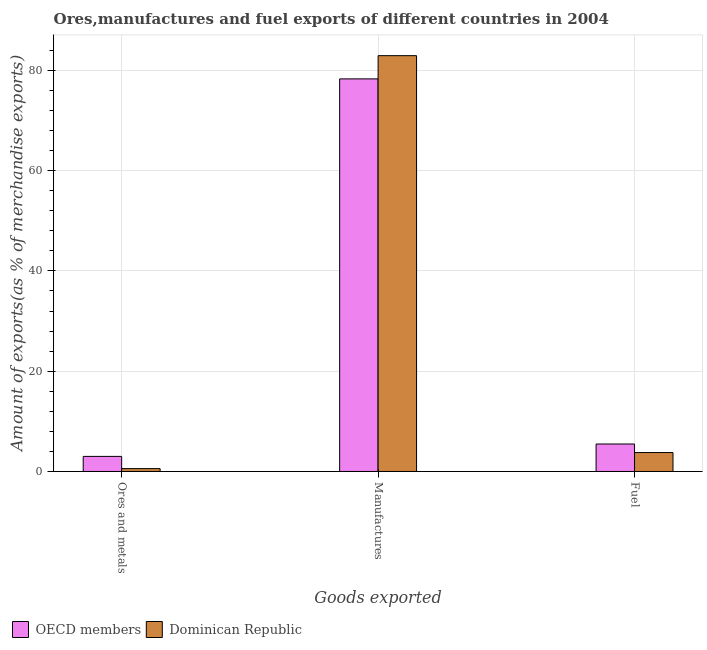How many groups of bars are there?
Your answer should be compact. 3. Are the number of bars per tick equal to the number of legend labels?
Offer a terse response. Yes. Are the number of bars on each tick of the X-axis equal?
Offer a terse response. Yes. What is the label of the 3rd group of bars from the left?
Give a very brief answer. Fuel. What is the percentage of manufactures exports in Dominican Republic?
Ensure brevity in your answer.  82.92. Across all countries, what is the maximum percentage of fuel exports?
Your answer should be compact. 5.48. Across all countries, what is the minimum percentage of ores and metals exports?
Give a very brief answer. 0.57. What is the total percentage of manufactures exports in the graph?
Keep it short and to the point. 161.21. What is the difference between the percentage of manufactures exports in Dominican Republic and that in OECD members?
Your answer should be very brief. 4.63. What is the difference between the percentage of fuel exports in OECD members and the percentage of ores and metals exports in Dominican Republic?
Keep it short and to the point. 4.91. What is the average percentage of fuel exports per country?
Provide a succinct answer. 4.63. What is the difference between the percentage of ores and metals exports and percentage of fuel exports in OECD members?
Give a very brief answer. -2.47. What is the ratio of the percentage of fuel exports in OECD members to that in Dominican Republic?
Give a very brief answer. 1.45. Is the difference between the percentage of manufactures exports in Dominican Republic and OECD members greater than the difference between the percentage of fuel exports in Dominican Republic and OECD members?
Your response must be concise. Yes. What is the difference between the highest and the second highest percentage of ores and metals exports?
Keep it short and to the point. 2.44. What is the difference between the highest and the lowest percentage of ores and metals exports?
Provide a succinct answer. 2.44. In how many countries, is the percentage of ores and metals exports greater than the average percentage of ores and metals exports taken over all countries?
Provide a succinct answer. 1. Is the sum of the percentage of ores and metals exports in OECD members and Dominican Republic greater than the maximum percentage of manufactures exports across all countries?
Keep it short and to the point. No. What does the 2nd bar from the left in Ores and metals represents?
Keep it short and to the point. Dominican Republic. Is it the case that in every country, the sum of the percentage of ores and metals exports and percentage of manufactures exports is greater than the percentage of fuel exports?
Ensure brevity in your answer.  Yes. How many bars are there?
Your answer should be very brief. 6. Are the values on the major ticks of Y-axis written in scientific E-notation?
Offer a terse response. No. Does the graph contain any zero values?
Your answer should be very brief. No. Where does the legend appear in the graph?
Provide a succinct answer. Bottom left. How are the legend labels stacked?
Give a very brief answer. Horizontal. What is the title of the graph?
Provide a succinct answer. Ores,manufactures and fuel exports of different countries in 2004. Does "Upper middle income" appear as one of the legend labels in the graph?
Keep it short and to the point. No. What is the label or title of the X-axis?
Your response must be concise. Goods exported. What is the label or title of the Y-axis?
Your answer should be compact. Amount of exports(as % of merchandise exports). What is the Amount of exports(as % of merchandise exports) in OECD members in Ores and metals?
Ensure brevity in your answer.  3.01. What is the Amount of exports(as % of merchandise exports) of Dominican Republic in Ores and metals?
Your answer should be compact. 0.57. What is the Amount of exports(as % of merchandise exports) in OECD members in Manufactures?
Your answer should be very brief. 78.29. What is the Amount of exports(as % of merchandise exports) of Dominican Republic in Manufactures?
Offer a terse response. 82.92. What is the Amount of exports(as % of merchandise exports) of OECD members in Fuel?
Your answer should be very brief. 5.48. What is the Amount of exports(as % of merchandise exports) in Dominican Republic in Fuel?
Offer a very short reply. 3.77. Across all Goods exported, what is the maximum Amount of exports(as % of merchandise exports) of OECD members?
Offer a terse response. 78.29. Across all Goods exported, what is the maximum Amount of exports(as % of merchandise exports) in Dominican Republic?
Keep it short and to the point. 82.92. Across all Goods exported, what is the minimum Amount of exports(as % of merchandise exports) in OECD members?
Make the answer very short. 3.01. Across all Goods exported, what is the minimum Amount of exports(as % of merchandise exports) of Dominican Republic?
Your response must be concise. 0.57. What is the total Amount of exports(as % of merchandise exports) in OECD members in the graph?
Offer a terse response. 86.78. What is the total Amount of exports(as % of merchandise exports) in Dominican Republic in the graph?
Offer a terse response. 87.26. What is the difference between the Amount of exports(as % of merchandise exports) of OECD members in Ores and metals and that in Manufactures?
Give a very brief answer. -75.28. What is the difference between the Amount of exports(as % of merchandise exports) of Dominican Republic in Ores and metals and that in Manufactures?
Provide a succinct answer. -82.35. What is the difference between the Amount of exports(as % of merchandise exports) in OECD members in Ores and metals and that in Fuel?
Your response must be concise. -2.47. What is the difference between the Amount of exports(as % of merchandise exports) in Dominican Republic in Ores and metals and that in Fuel?
Keep it short and to the point. -3.2. What is the difference between the Amount of exports(as % of merchandise exports) of OECD members in Manufactures and that in Fuel?
Keep it short and to the point. 72.81. What is the difference between the Amount of exports(as % of merchandise exports) of Dominican Republic in Manufactures and that in Fuel?
Keep it short and to the point. 79.15. What is the difference between the Amount of exports(as % of merchandise exports) of OECD members in Ores and metals and the Amount of exports(as % of merchandise exports) of Dominican Republic in Manufactures?
Keep it short and to the point. -79.91. What is the difference between the Amount of exports(as % of merchandise exports) of OECD members in Ores and metals and the Amount of exports(as % of merchandise exports) of Dominican Republic in Fuel?
Your response must be concise. -0.76. What is the difference between the Amount of exports(as % of merchandise exports) of OECD members in Manufactures and the Amount of exports(as % of merchandise exports) of Dominican Republic in Fuel?
Your answer should be very brief. 74.52. What is the average Amount of exports(as % of merchandise exports) of OECD members per Goods exported?
Offer a very short reply. 28.93. What is the average Amount of exports(as % of merchandise exports) of Dominican Republic per Goods exported?
Make the answer very short. 29.09. What is the difference between the Amount of exports(as % of merchandise exports) in OECD members and Amount of exports(as % of merchandise exports) in Dominican Republic in Ores and metals?
Offer a very short reply. 2.44. What is the difference between the Amount of exports(as % of merchandise exports) of OECD members and Amount of exports(as % of merchandise exports) of Dominican Republic in Manufactures?
Your response must be concise. -4.63. What is the difference between the Amount of exports(as % of merchandise exports) of OECD members and Amount of exports(as % of merchandise exports) of Dominican Republic in Fuel?
Keep it short and to the point. 1.71. What is the ratio of the Amount of exports(as % of merchandise exports) of OECD members in Ores and metals to that in Manufactures?
Your answer should be very brief. 0.04. What is the ratio of the Amount of exports(as % of merchandise exports) in Dominican Republic in Ores and metals to that in Manufactures?
Ensure brevity in your answer.  0.01. What is the ratio of the Amount of exports(as % of merchandise exports) in OECD members in Ores and metals to that in Fuel?
Offer a terse response. 0.55. What is the ratio of the Amount of exports(as % of merchandise exports) of Dominican Republic in Ores and metals to that in Fuel?
Your answer should be compact. 0.15. What is the ratio of the Amount of exports(as % of merchandise exports) of OECD members in Manufactures to that in Fuel?
Make the answer very short. 14.29. What is the ratio of the Amount of exports(as % of merchandise exports) in Dominican Republic in Manufactures to that in Fuel?
Your answer should be compact. 21.98. What is the difference between the highest and the second highest Amount of exports(as % of merchandise exports) of OECD members?
Provide a succinct answer. 72.81. What is the difference between the highest and the second highest Amount of exports(as % of merchandise exports) in Dominican Republic?
Provide a succinct answer. 79.15. What is the difference between the highest and the lowest Amount of exports(as % of merchandise exports) in OECD members?
Your response must be concise. 75.28. What is the difference between the highest and the lowest Amount of exports(as % of merchandise exports) of Dominican Republic?
Ensure brevity in your answer.  82.35. 